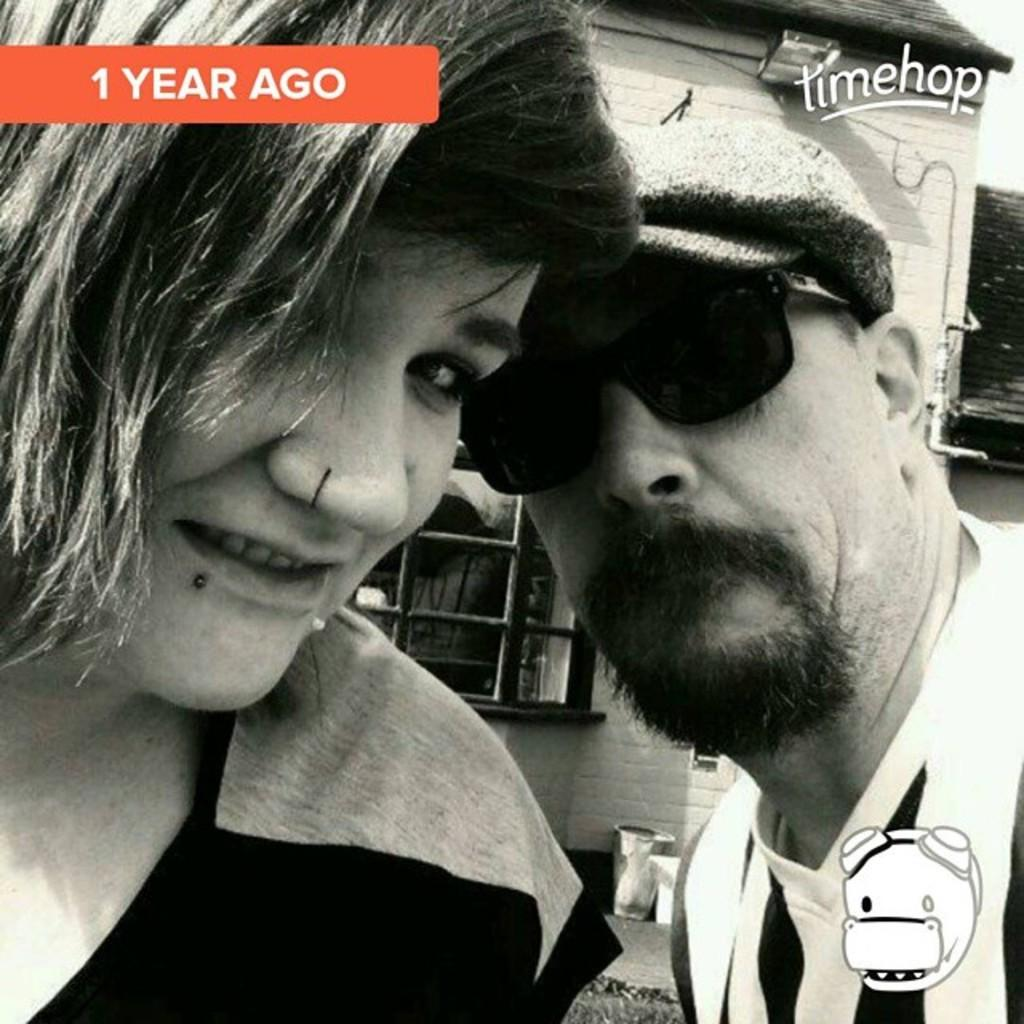Who is present in the image? There is a woman and a man in the image. What is the woman doing in the image? The woman is smiling in the image. What is the man wearing in the image? The man is wearing goggles in the image. What can be seen in the background of the image? There is a house with a window and objects and stickers visible in the background. What type of net is being used by the creator in the image? There is no creator or net present in the image. What sense is being stimulated by the objects in the background? The provided facts do not mention any specific senses being stimulated by the objects in the background. 